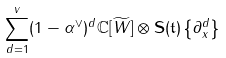Convert formula to latex. <formula><loc_0><loc_0><loc_500><loc_500>\sum _ { d = 1 } ^ { v } ( 1 - \alpha ^ { \vee } ) ^ { d } \mathbb { C } [ \widetilde { W } ] \otimes \mathbf S ( \mathfrak t ) \left \{ \partial _ { x } ^ { d } \right \}</formula> 